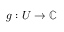Convert formula to latex. <formula><loc_0><loc_0><loc_500><loc_500>g \colon U \to \mathbb { C }</formula> 